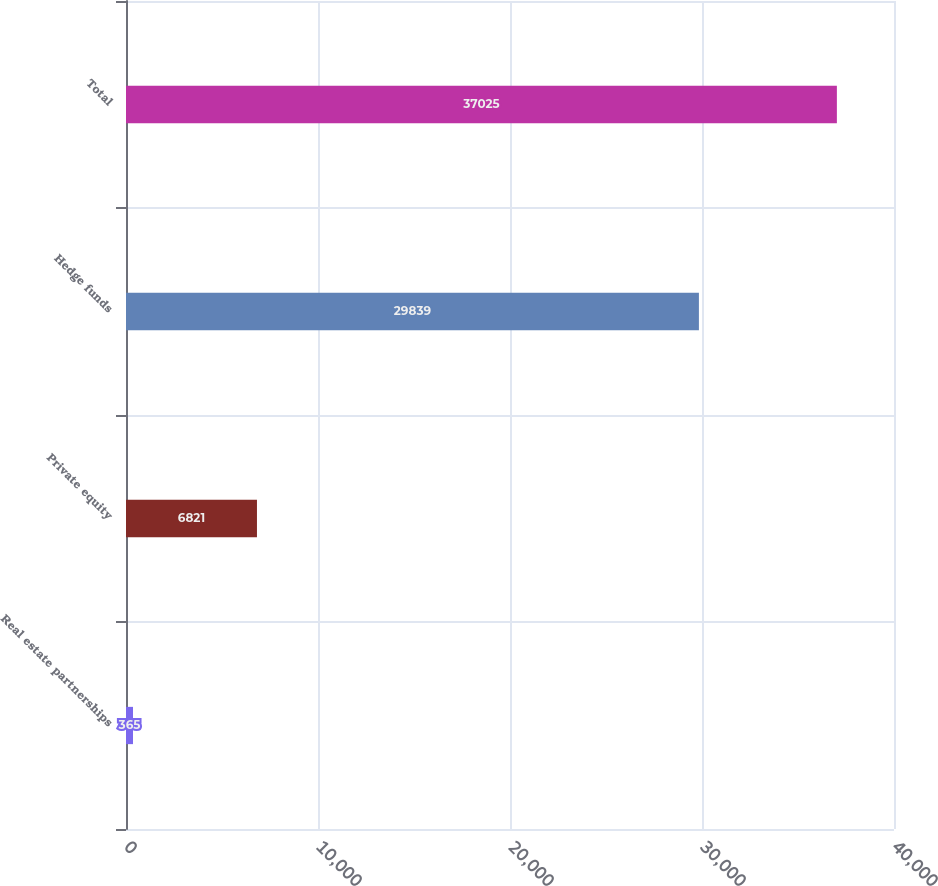Convert chart to OTSL. <chart><loc_0><loc_0><loc_500><loc_500><bar_chart><fcel>Real estate partnerships<fcel>Private equity<fcel>Hedge funds<fcel>Total<nl><fcel>365<fcel>6821<fcel>29839<fcel>37025<nl></chart> 